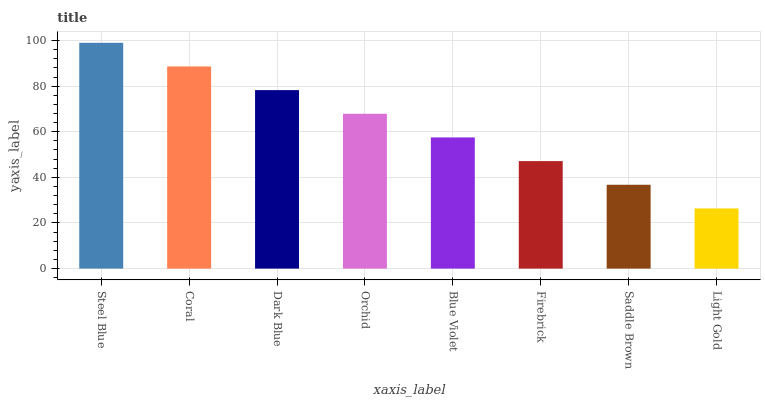Is Light Gold the minimum?
Answer yes or no. Yes. Is Steel Blue the maximum?
Answer yes or no. Yes. Is Coral the minimum?
Answer yes or no. No. Is Coral the maximum?
Answer yes or no. No. Is Steel Blue greater than Coral?
Answer yes or no. Yes. Is Coral less than Steel Blue?
Answer yes or no. Yes. Is Coral greater than Steel Blue?
Answer yes or no. No. Is Steel Blue less than Coral?
Answer yes or no. No. Is Orchid the high median?
Answer yes or no. Yes. Is Blue Violet the low median?
Answer yes or no. Yes. Is Blue Violet the high median?
Answer yes or no. No. Is Steel Blue the low median?
Answer yes or no. No. 